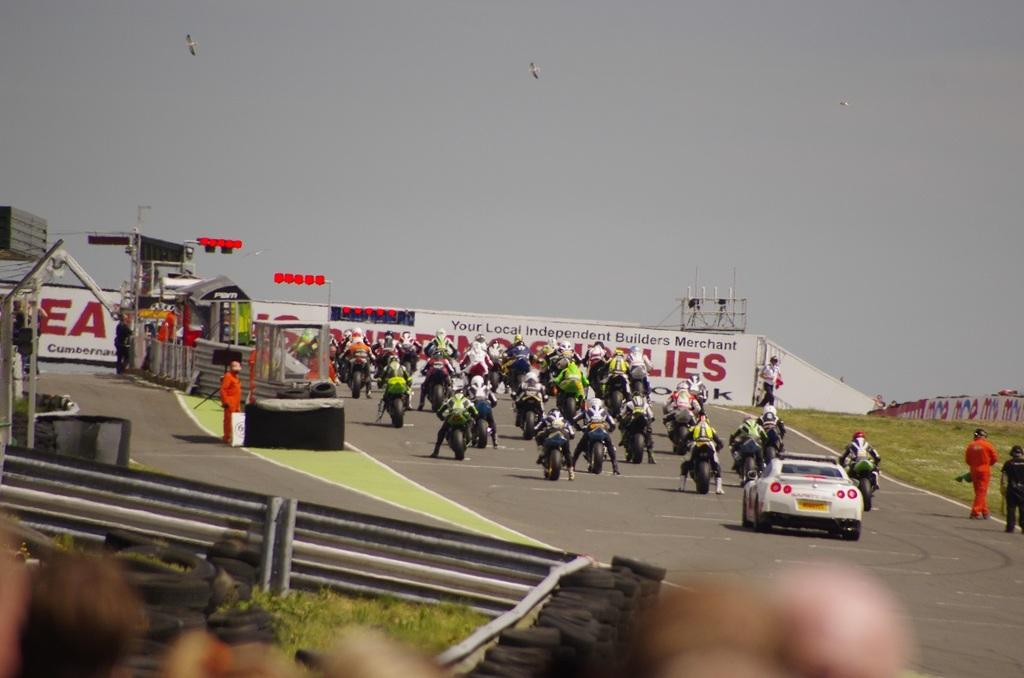Provide a one-sentence caption for the provided image. A motorcycle race is preparing to begin sponsored by Your Local independent Builders Merchant. 